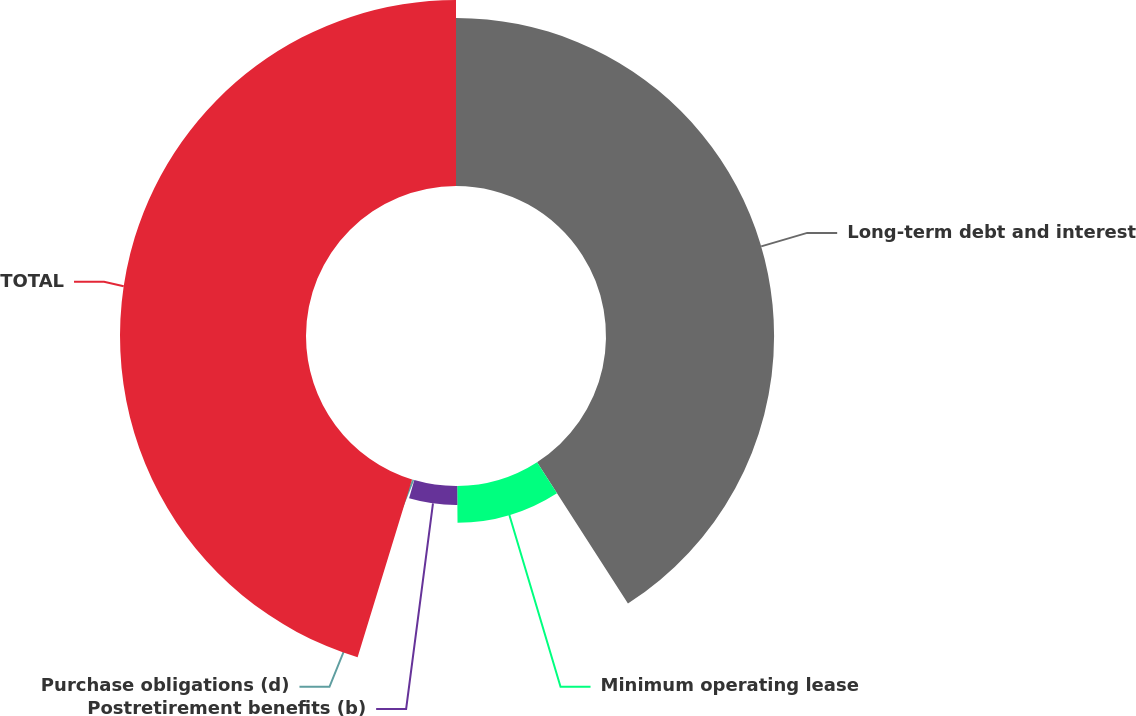Convert chart to OTSL. <chart><loc_0><loc_0><loc_500><loc_500><pie_chart><fcel>Long-term debt and interest<fcel>Minimum operating lease<fcel>Postretirement benefits (b)<fcel>Purchase obligations (d)<fcel>TOTAL<nl><fcel>40.91%<fcel>8.96%<fcel>4.61%<fcel>0.25%<fcel>45.27%<nl></chart> 